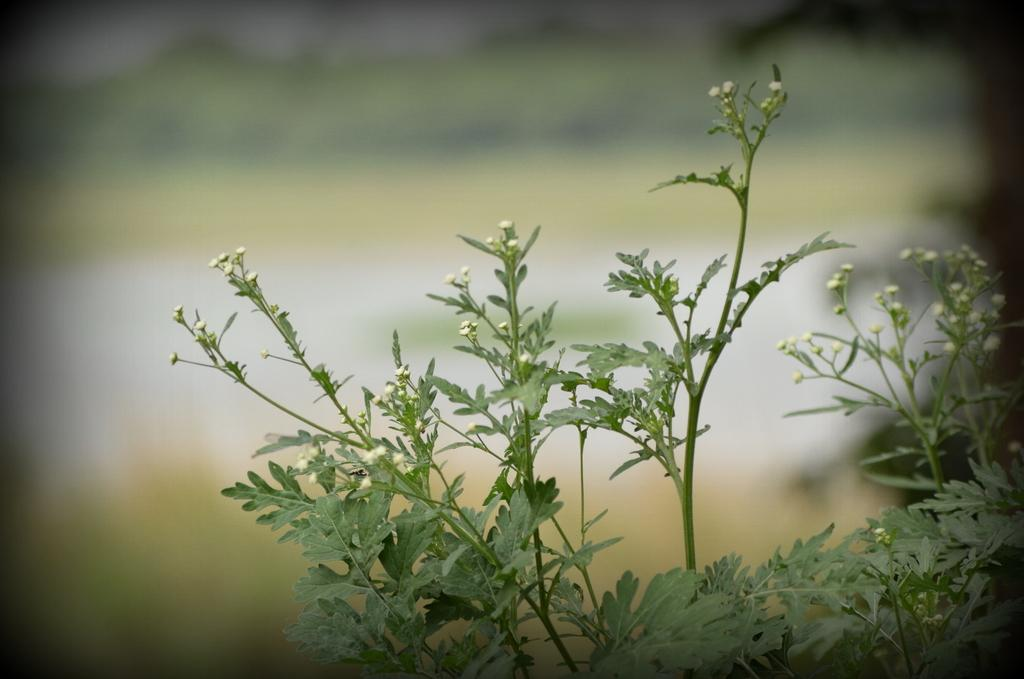What type of living organisms can be seen in the picture? Plants can be seen in the picture. What specific feature can be observed on the plants? The plants have tiny flowers. Can you describe the background of the image? The background of the image is blurred. What type of cactus can be seen in the image? There is no cactus present in the image; the plants in the image have tiny flowers. What is the chain used for in the image? There is no chain present in the image. 